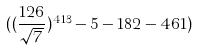Convert formula to latex. <formula><loc_0><loc_0><loc_500><loc_500>( ( \frac { 1 2 6 } { \sqrt { 7 } } ) ^ { 4 1 3 } - 5 - 1 8 2 - 4 6 1 )</formula> 